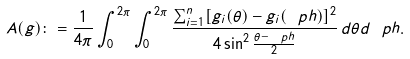<formula> <loc_0><loc_0><loc_500><loc_500>A ( g ) \colon = \frac { 1 } { 4 \pi } \int _ { 0 } ^ { 2 \pi } \int _ { 0 } ^ { 2 \pi } \frac { \sum _ { i = 1 } ^ { n } [ g _ { i } ( \theta ) - g _ { i } ( \ p h ) ] ^ { 2 } } { 4 \sin ^ { 2 } \frac { \theta - \ p h } { 2 } } \, d \theta d \ p h .</formula> 